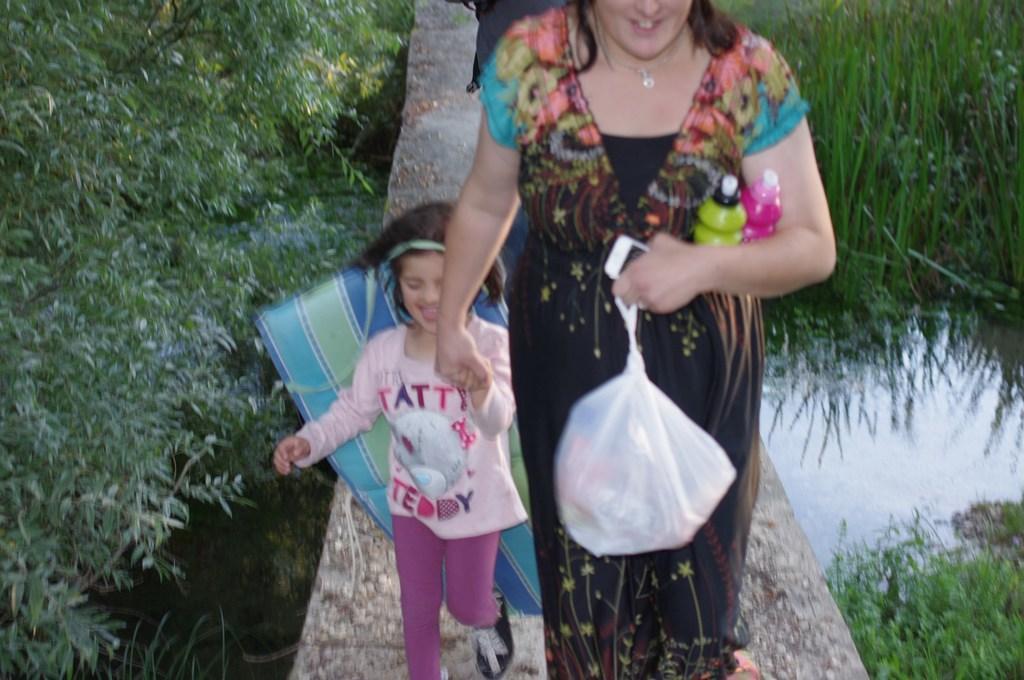Describe this image in one or two sentences. In this image I can see a girl and a woman. I can see she is holding a phone and a white colour plastic cover. I can also see few bottles over here. In the background I can see bushes and water. 